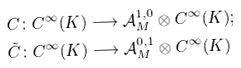<formula> <loc_0><loc_0><loc_500><loc_500>C \colon C ^ { \infty } ( K ) & \longrightarrow \mathcal { A } _ { M } ^ { 1 , 0 } \otimes C ^ { \infty } ( K ) ; \\ \tilde { C } \colon C ^ { \infty } ( K ) & \longrightarrow \mathcal { A } _ { M } ^ { 0 , 1 } \otimes C ^ { \infty } ( K )</formula> 